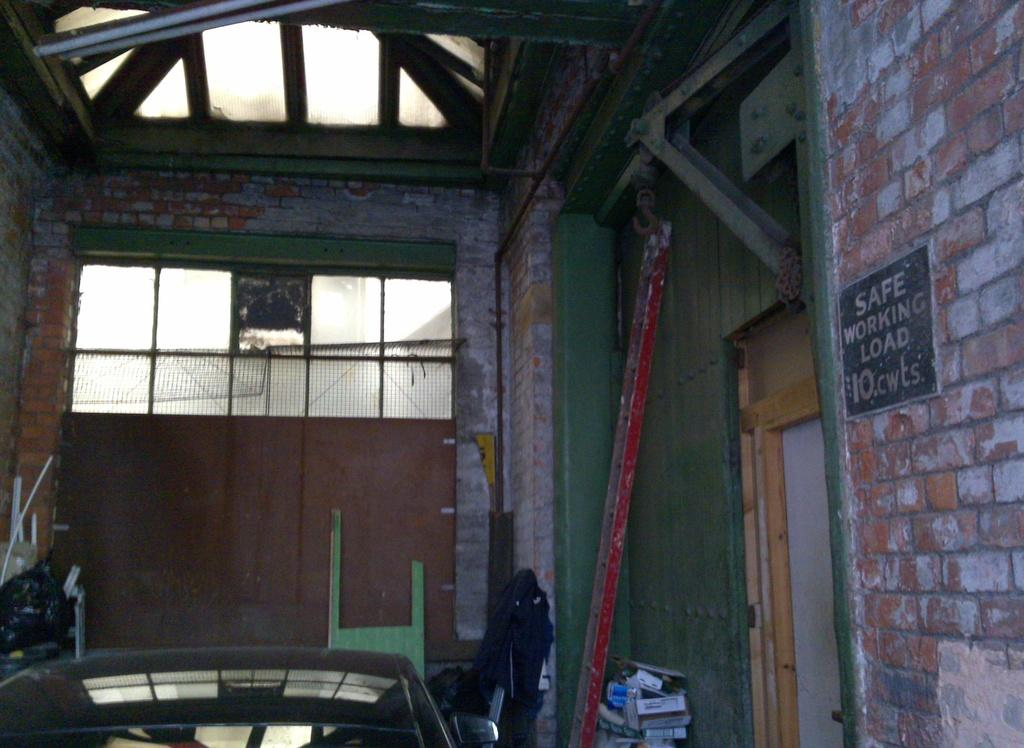What type of building is in the picture? There is a house in the picture. Can you describe the door of the house? The house has a wooden door on the right side. What can be found inside the house? There are objects placed in the house. What material is used for the stone on the wall? The stone placed on the wall on the right side is made of stone. What type of jelly can be seen dripping from the roof of the house in the image? There is no jelly present in the image, and therefore no such activity can be observed. Is there a hole in the wall of the house in the image? The provided facts do not mention any holes in the wall of the house, so we cannot definitively answer this question. 